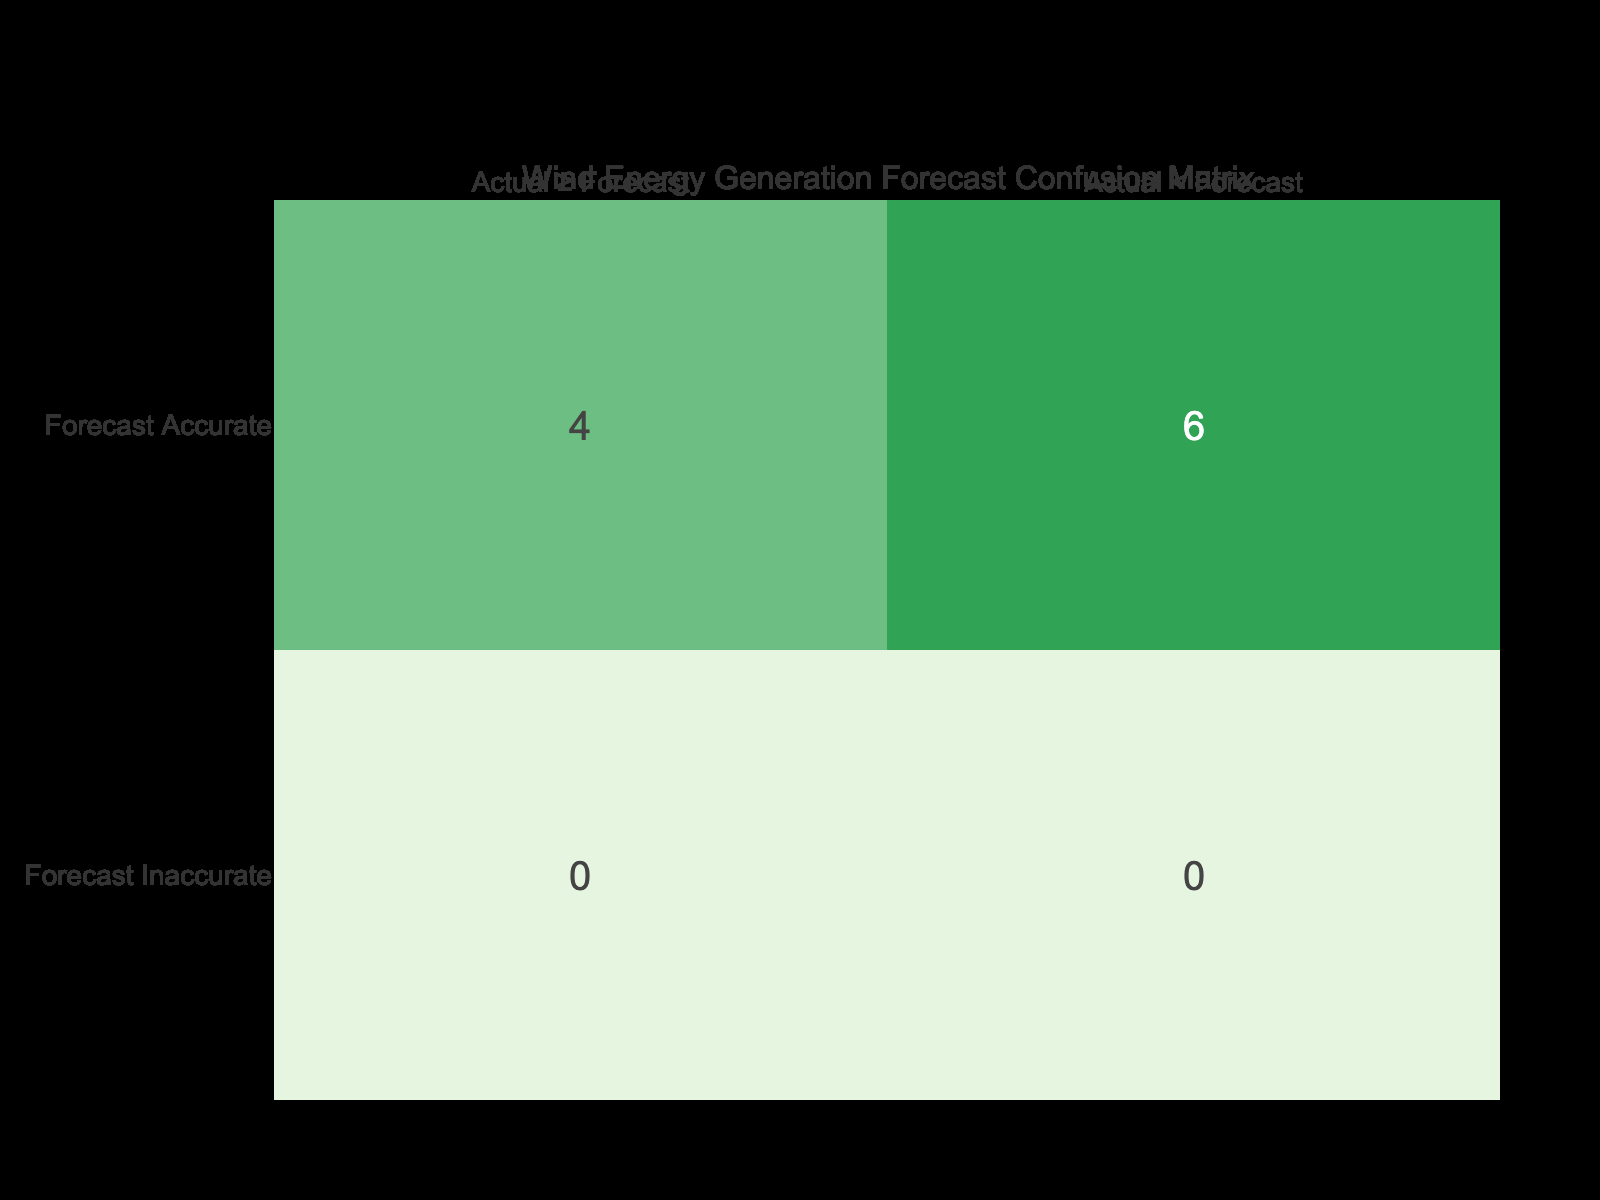What is the total number of True Positives in the confusion matrix? True Positives are counted when the forecast accuracy is 1, and the actual generation is greater than or equal to the forecasted generation. In this dataset, the turbines that meet these criteria are Mitsubishi MWT 1000 (12500 ≥ 12000) and Enercon E40 (23000 ≥ 22000), resulting in 2 True Positives.
Answer: 2 What is the total number of False Negatives in the confusion matrix? False Negatives occur when the forecast accuracy is 0 and the actual generation is greater than or equal to the forecasted generation. In this dataset, there are no turbines that fit this category, so the total is 0.
Answer: 0 How many models had actual generation lower than their forecast yet were marked as inaccurate? We need to identify rows where the forecast accuracy is 0 and actual generation is less than forecasted generation. From the dataset, GE 1.5sle, Siemens SWT 2.3, Nordex N60/1300, and Siemens SWT 3.6 are such models, totaling 4 models.
Answer: 4 What is the difference in the number of True Negatives and False Positives? True Negatives are the turbines where forecast accuracy is 1 and actual generation is less than forecasted. In this dataset, there are no such turbines. Thus, True Negatives = 0. False Positives are counted when forecast accuracy is 0 and actual generation is less than forecasted; this occurs for GE 1.5sle and Siemens SWT 2.3, for a total of 2 False Positives. The difference is 0 - 2 = -2.
Answer: -2 Is it true that all turbine models with forecast accuracy of 1 had an actual generation greater than their forecasted generation? To verify this, we look through the models with forecast accuracy of 1. These are Vestas V90 3.0 (26000 > 25000), Mitsubishi MWT 1000 (12500 > 12000), Enercon E40 (23000 > 22000), and Vestas V136 3.45 (36000 > 35000). Since all these instances confirm this statement, the answer is yes.
Answer: Yes What is the average actual generation of the turbine models that had forecast accuracy of 0? We'll sum the actual generation values for models with forecast accuracy of 0: 14500 (GE 1.5sle) + 19500 (Siemens SWT 2.3) + 17500 (Nordex N60/1300) + 15900 (Gamesa G80) + 29000 (Siemens SWT 3.6) = 109400. Combining this with the count of 5 models gives an average of 109400 / 5 = 21880.
Answer: 21880 How many turbine models had forecasted generation above 25000 kWh and were inaccurate? From the dataset, the turbine models having forecasted generation above 25000 kWh are Vestas V90 3.0 (25000), GE 2.5-132 (28000), and Siemens SWT 3.6 (30000). Out of these, only Vestas V90 3.0 and GE 2.5-132 are marked as inaccurate, leading to a total of 2 models.
Answer: 2 